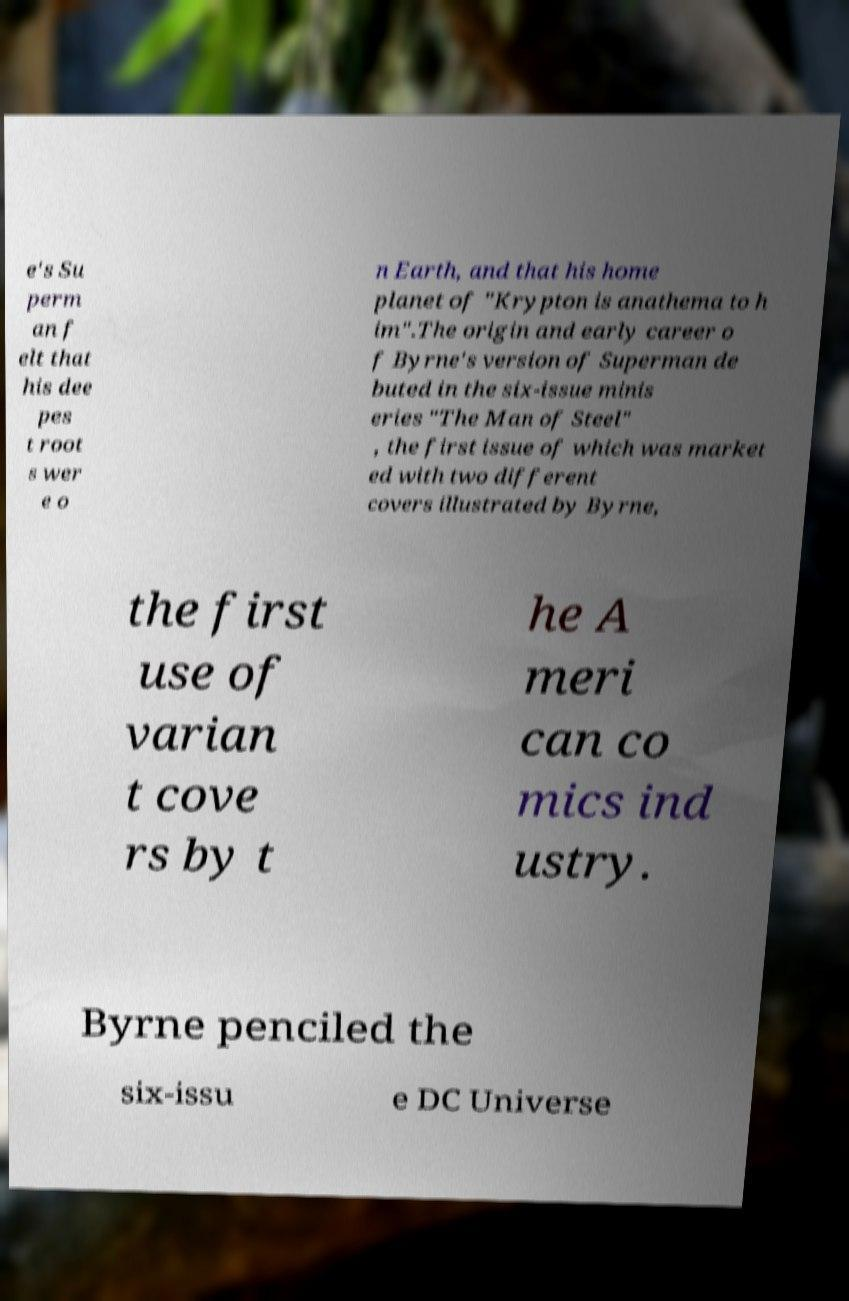Please read and relay the text visible in this image. What does it say? e's Su perm an f elt that his dee pes t root s wer e o n Earth, and that his home planet of "Krypton is anathema to h im".The origin and early career o f Byrne's version of Superman de buted in the six-issue minis eries "The Man of Steel" , the first issue of which was market ed with two different covers illustrated by Byrne, the first use of varian t cove rs by t he A meri can co mics ind ustry. Byrne penciled the six-issu e DC Universe 